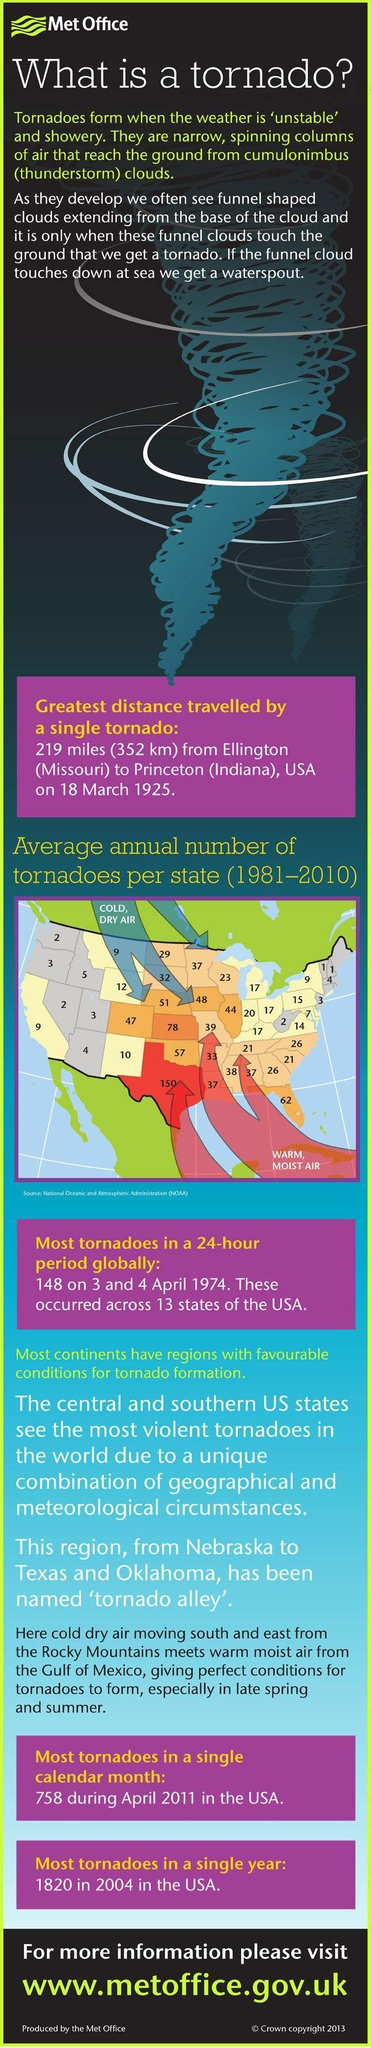Which U.S. state has reported the second-highest average annual number of tornadoes during 1981-2010 - California, New Mexico, Kansas, Montana?
Answer the question with a short phrase. Kansas What is the average annual number of tornadoes in New Mexico during 1981-2010? 10 What is the average annual number of tornadoes in California during 1981-2010? 9 Which U.S. state has reported the highest average annual number of tornadoes during 1981-2010 - California, Texas, Florida, Washington? Texas 